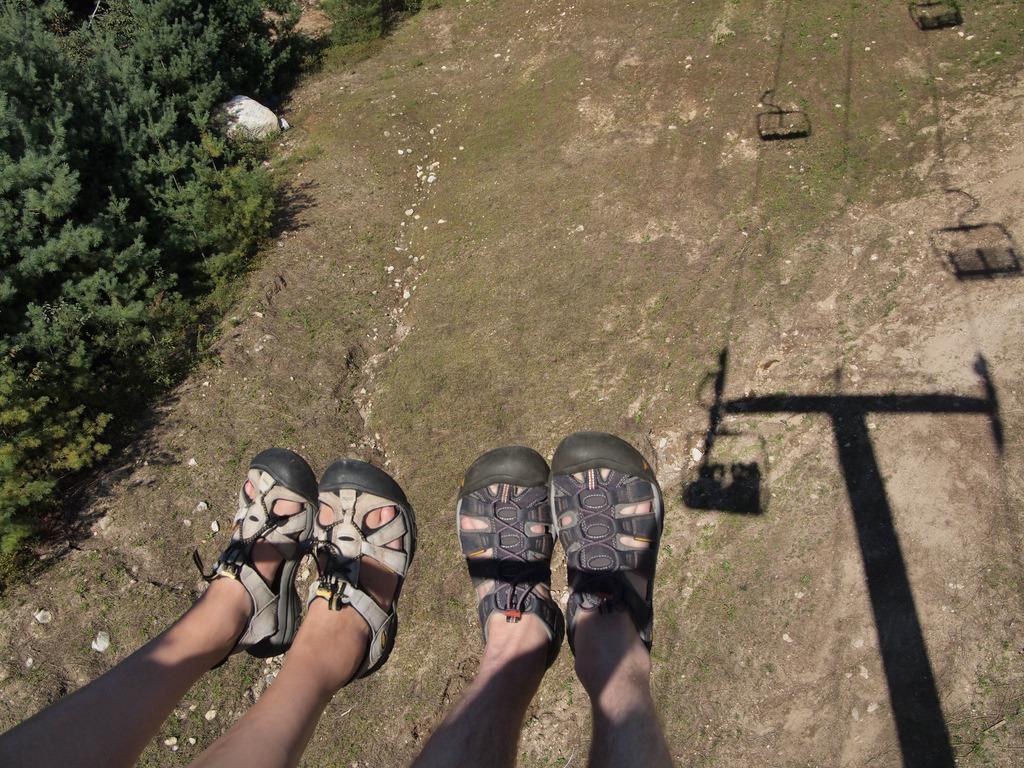Describe this image in one or two sentences. On the left side, there is a person wearing slippers. Beside this person, there is another person wearing slippers. On the right side, there is a shadow of a pole which is having threads. To these threads, there are some vehicles connected. In the background, there are trees, stones and grass on the ground. 